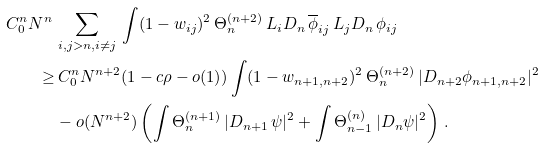Convert formula to latex. <formula><loc_0><loc_0><loc_500><loc_500>C _ { 0 } ^ { n } N ^ { n } \, & \sum _ { i , j > n , i \neq j } \, \int ( 1 - w _ { i j } ) ^ { 2 } \, \Theta ^ { ( n + 2 ) } _ { n } \, L _ { i } D _ { n } \, \overline { \phi } _ { i j } \, L _ { j } D _ { n } \, \phi _ { i j } \\ \geq & \, C _ { 0 } ^ { n } N ^ { n + 2 } ( 1 - c \rho - o ( 1 ) ) \int ( 1 - w _ { n + 1 , n + 2 } ) ^ { 2 } \, \Theta ^ { ( n + 2 ) } _ { n } \, | D _ { n + 2 } \phi _ { n + 1 , n + 2 } | ^ { 2 } \\ & - o ( N ^ { n + 2 } ) \left ( \int \Theta ^ { ( n + 1 ) } _ { n } \, | D _ { n + 1 } \, \psi | ^ { 2 } + \int \Theta _ { n - 1 } ^ { ( n ) } \, | D _ { n } \psi | ^ { 2 } \right ) \, .</formula> 